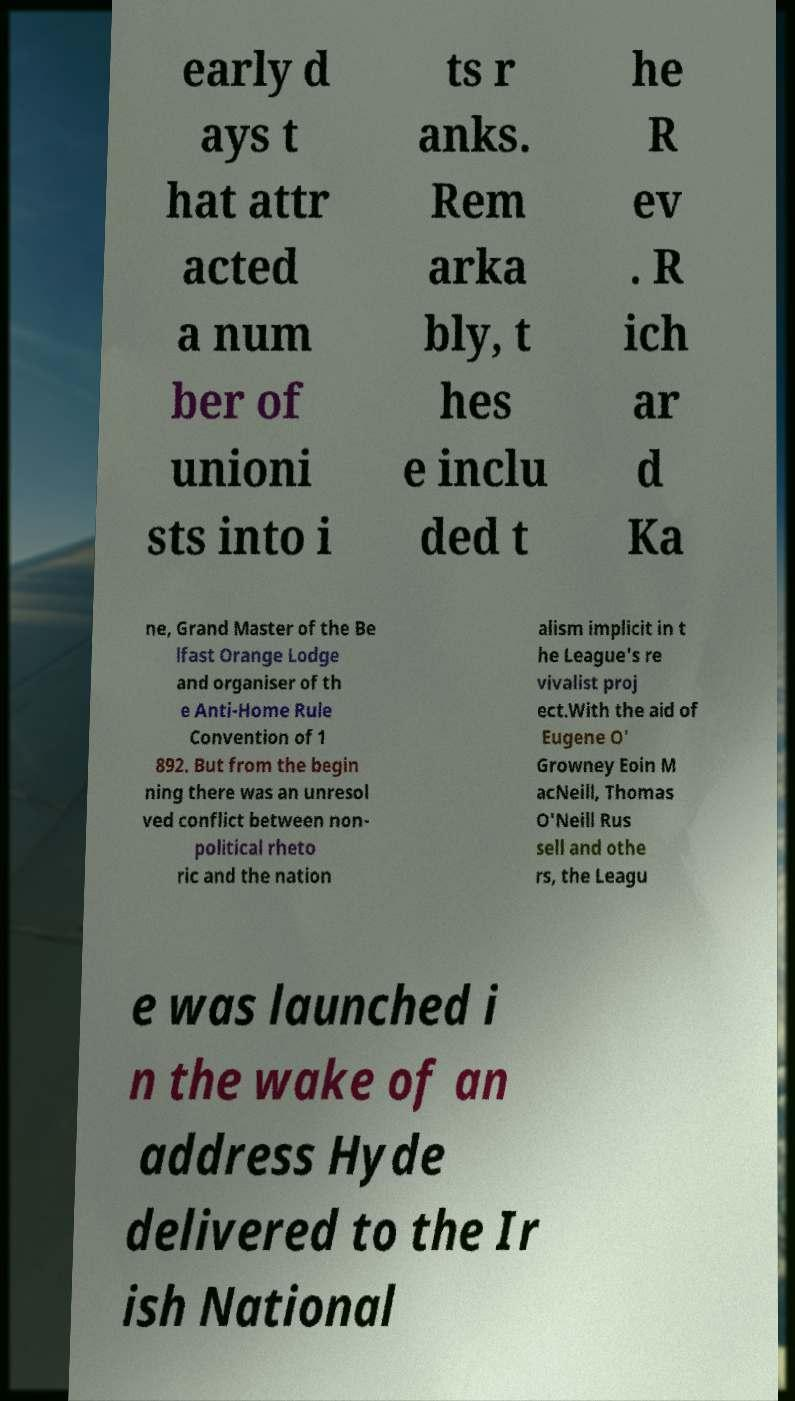What messages or text are displayed in this image? I need them in a readable, typed format. early d ays t hat attr acted a num ber of unioni sts into i ts r anks. Rem arka bly, t hes e inclu ded t he R ev . R ich ar d Ka ne, Grand Master of the Be lfast Orange Lodge and organiser of th e Anti-Home Rule Convention of 1 892. But from the begin ning there was an unresol ved conflict between non- political rheto ric and the nation alism implicit in t he League's re vivalist proj ect.With the aid of Eugene O' Growney Eoin M acNeill, Thomas O'Neill Rus sell and othe rs, the Leagu e was launched i n the wake of an address Hyde delivered to the Ir ish National 